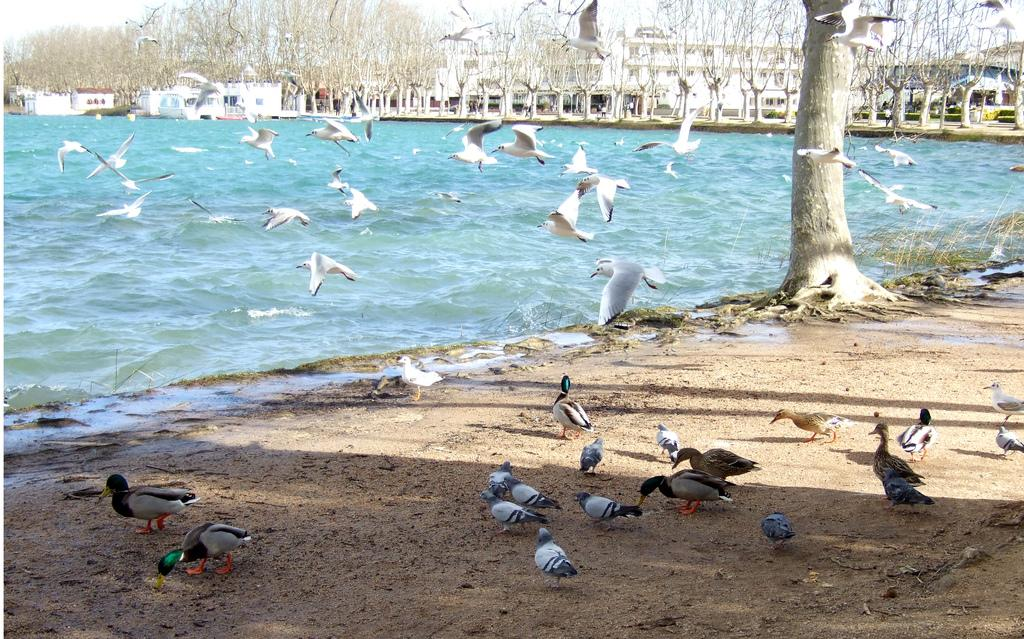What type of animals can be seen in the image? Birds can be seen in the image. What is visible beneath the birds and other elements in the image? The ground is visible in the image. What type of vegetation is present in the image? There are trees and plants in the image. What is the source of water in the image? There is water visible in the image. What type of structures are present in the image? There are buildings in the image. Who else is present in the image besides the birds? There are people in the image. What is visible above the birds and other elements in the image? The sky is visible in the image. What type of line can be seen dividing the scene in the image? There is no line dividing the scene in the image; it is a continuous landscape with no visible dividers. 